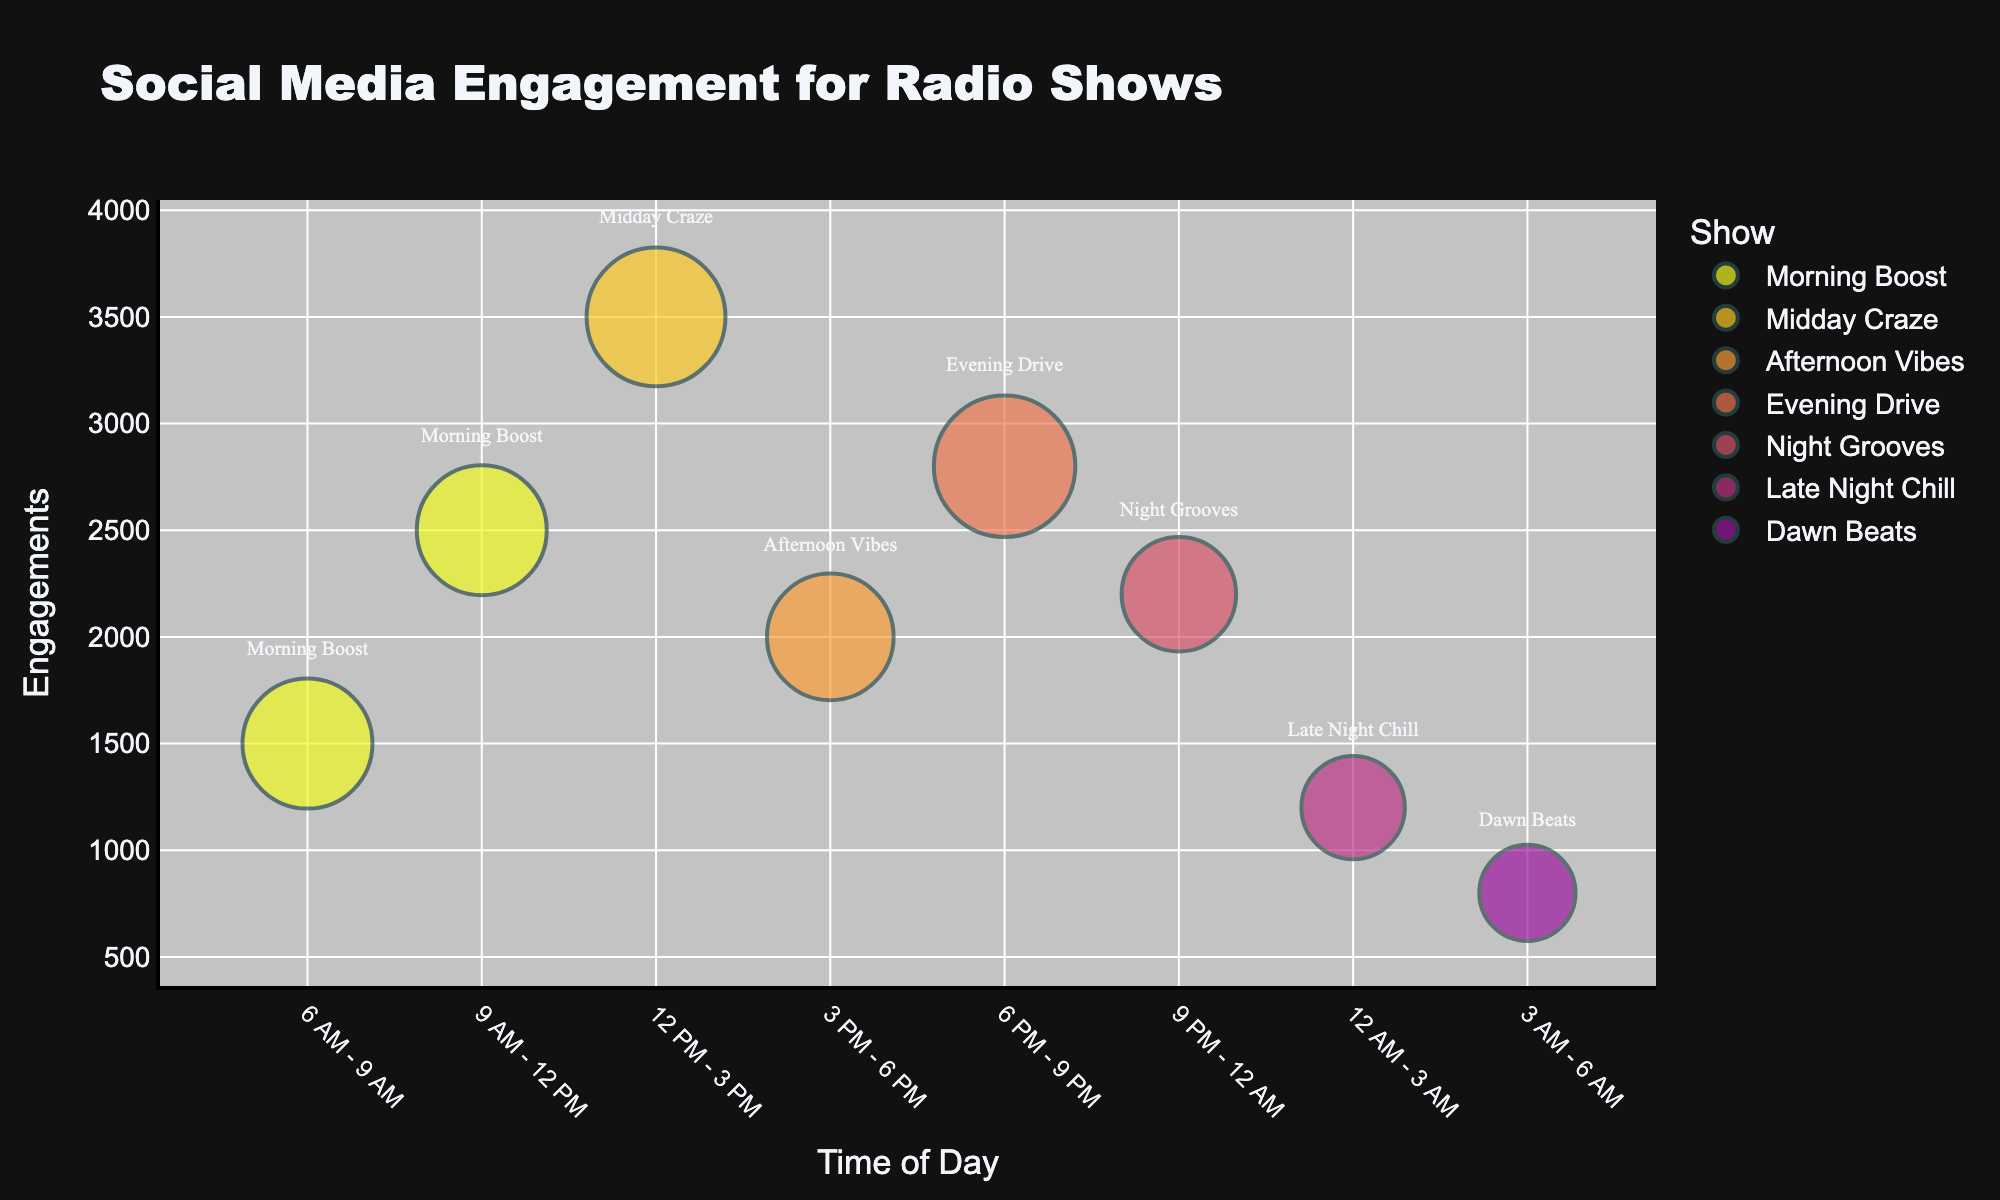What's the title of the chart? The title is displayed prominently at the top of the chart.
Answer: Social Media Engagement for Radio Shows How many radio shows are represented in the bubble chart? Each unique color and label represent a different radio show. By counting these, we find there are eight shows.
Answer: Eight At what time of day does "Midday Craze" have its highest engagement? By looking at the "Midday Craze" data points and finding the corresponding time on the x-axis where the bubble is largest in size.
Answer: 12 PM - 3 PM Which time of day has the lowest engagement? Observing the y-axis for the lowest value bubble, we see that it is around "Dawn Beats".
Answer: 3 AM - 6 AM Which radio show has the highest number of engagements? Comparing the height of each bubble on the y-axis, we see the highest engagement is "Midday Craze".
Answer: Midday Craze Does "Morning Boost" have higher engagements between 6 AM - 9 AM or 9 AM - 12 PM? Checking the "Morning Boost" data points, the engagements are higher from 9 AM - 12 PM compared to 6 AM - 9 AM.
Answer: 9 AM - 12 PM Which show has the smallest bubble size? The bubble size represents the followers. Identifying the smallest bubble visually leads to "Dawn Beats".
Answer: Dawn Beats Between "Evening Drive" and "Afternoon Vibes", which has higher engagements and at what time of day? Comparing both show's bubbles on the y-axis, "Evening Drive" has higher engagements, observed around 6 PM - 9 PM.
Answer: Evening Drive (6 PM - 9 PM) How does the engagement of "Night Grooves" compare between 9 PM - 12 AM and 12 AM - 3 AM? Comparing the bubbles, "Night Grooves" has higher engagements from 9 PM - 12 AM.
Answer: 9 PM - 12 AM What can be inferred about the relationship between followers and engagement from the bubble chart? Observing the chart, larger bubbles often have higher engagements, indicating a potential positive correlation between more followers and higher engagement.
Answer: Positive correlation 